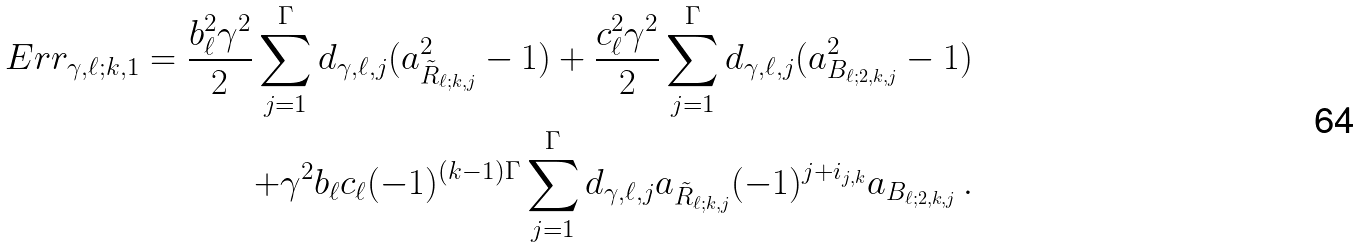<formula> <loc_0><loc_0><loc_500><loc_500>E r r _ { \gamma , \ell ; k , 1 } = \frac { b _ { \ell } ^ { 2 } \gamma ^ { 2 } } { 2 } \sum _ { j = 1 } ^ { \Gamma } d _ { \gamma , \ell , j } ( a _ { \tilde { R } _ { \ell ; k , j } } ^ { 2 } - 1 ) + \frac { c _ { \ell } ^ { 2 } \gamma ^ { 2 } } { 2 } \sum _ { j = 1 } ^ { \Gamma } d _ { \gamma , \ell , j } ( a _ { B _ { \ell ; 2 , k , j } } ^ { 2 } - 1 ) \\ + \gamma ^ { 2 } b _ { \ell } c _ { \ell } ( - 1 ) ^ { ( k - 1 ) \Gamma } \sum _ { j = 1 } ^ { \Gamma } d _ { \gamma , \ell , j } a _ { \tilde { R } _ { \ell ; k , j } } ( - 1 ) ^ { j + i _ { j , k } } a _ { B _ { \ell ; 2 , k , j } } \, .</formula> 